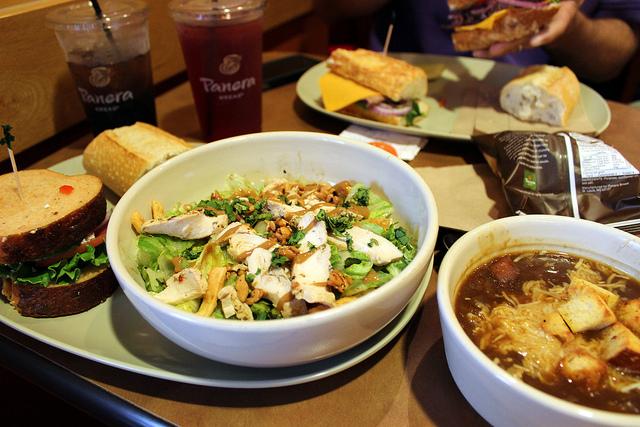What meat is in the salad?
Be succinct. Chicken. What restaurant is this?
Short answer required. Panera. Are there chips on the table?
Answer briefly. Yes. 